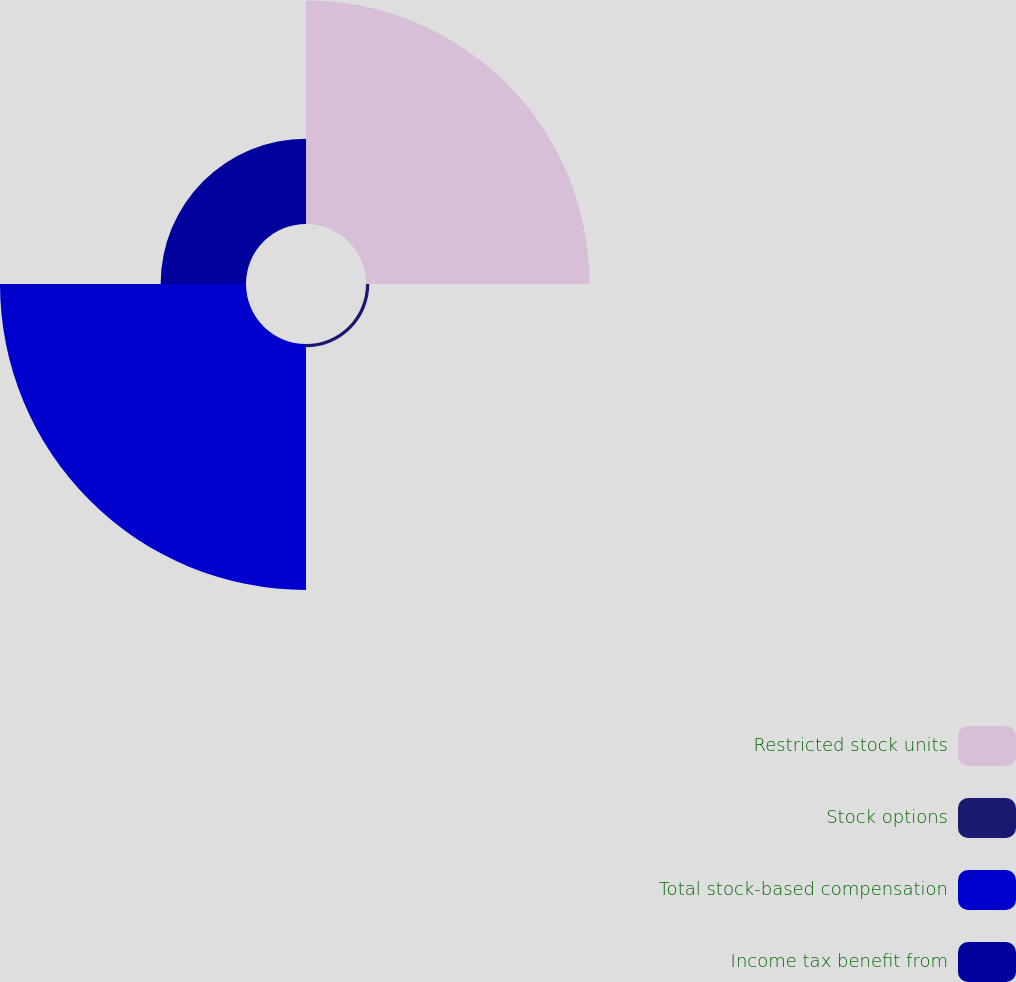Convert chart to OTSL. <chart><loc_0><loc_0><loc_500><loc_500><pie_chart><fcel>Restricted stock units<fcel>Stock options<fcel>Total stock-based compensation<fcel>Income tax benefit from<nl><fcel>40.05%<fcel>0.59%<fcel>44.06%<fcel>15.29%<nl></chart> 